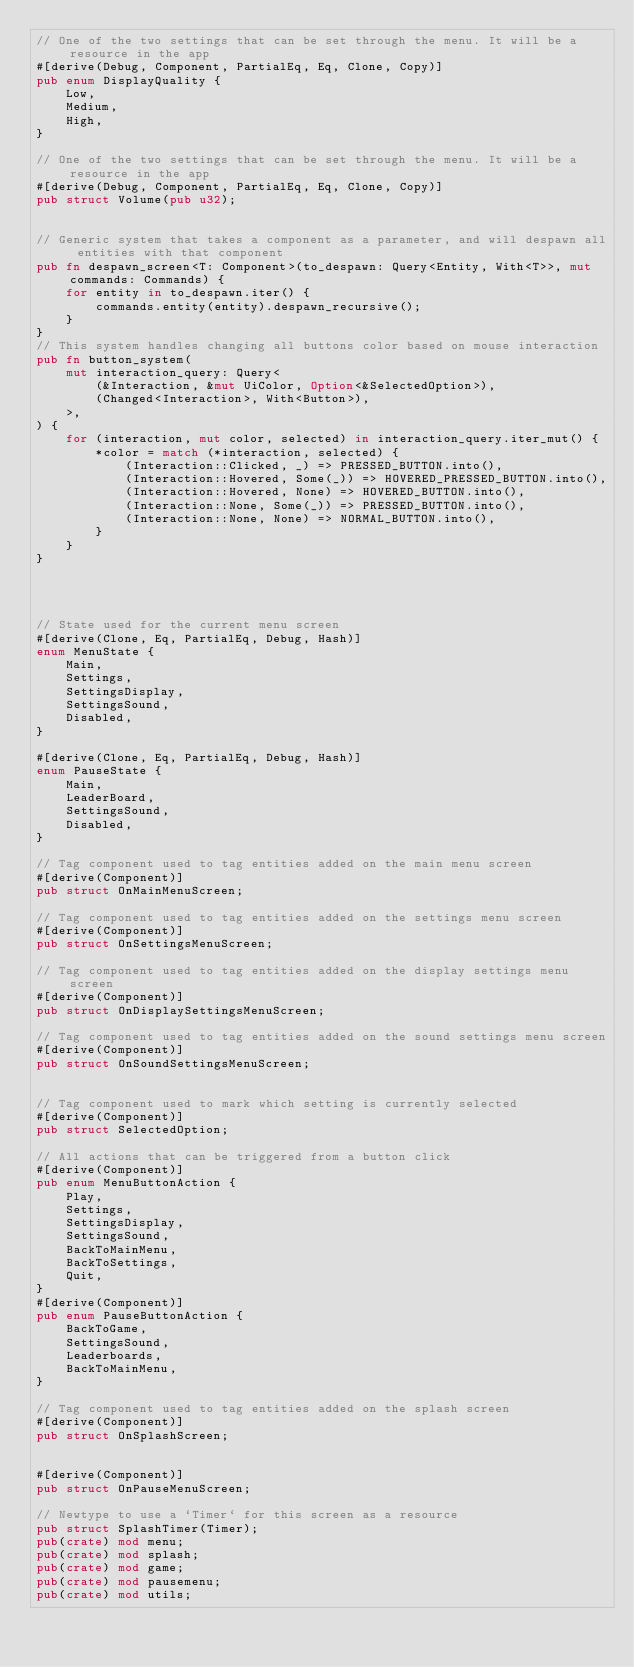Convert code to text. <code><loc_0><loc_0><loc_500><loc_500><_Rust_>// One of the two settings that can be set through the menu. It will be a resource in the app
#[derive(Debug, Component, PartialEq, Eq, Clone, Copy)]
pub enum DisplayQuality {
    Low,
    Medium,
    High,
}

// One of the two settings that can be set through the menu. It will be a resource in the app
#[derive(Debug, Component, PartialEq, Eq, Clone, Copy)]
pub struct Volume(pub u32);


// Generic system that takes a component as a parameter, and will despawn all entities with that component
pub fn despawn_screen<T: Component>(to_despawn: Query<Entity, With<T>>, mut commands: Commands) {
    for entity in to_despawn.iter() {
        commands.entity(entity).despawn_recursive();
    }
}
// This system handles changing all buttons color based on mouse interaction
pub fn button_system(
    mut interaction_query: Query<
        (&Interaction, &mut UiColor, Option<&SelectedOption>),
        (Changed<Interaction>, With<Button>),
    >,
) {
    for (interaction, mut color, selected) in interaction_query.iter_mut() {
        *color = match (*interaction, selected) {
            (Interaction::Clicked, _) => PRESSED_BUTTON.into(),
            (Interaction::Hovered, Some(_)) => HOVERED_PRESSED_BUTTON.into(),
            (Interaction::Hovered, None) => HOVERED_BUTTON.into(),
            (Interaction::None, Some(_)) => PRESSED_BUTTON.into(),
            (Interaction::None, None) => NORMAL_BUTTON.into(),
        }
    }
}




// State used for the current menu screen
#[derive(Clone, Eq, PartialEq, Debug, Hash)]
enum MenuState {
    Main,
    Settings,
    SettingsDisplay,
    SettingsSound,
    Disabled,
}

#[derive(Clone, Eq, PartialEq, Debug, Hash)]
enum PauseState {
    Main,
    LeaderBoard,
    SettingsSound,
    Disabled,
}

// Tag component used to tag entities added on the main menu screen
#[derive(Component)]
pub struct OnMainMenuScreen;

// Tag component used to tag entities added on the settings menu screen
#[derive(Component)]
pub struct OnSettingsMenuScreen;

// Tag component used to tag entities added on the display settings menu screen
#[derive(Component)]
pub struct OnDisplaySettingsMenuScreen;

// Tag component used to tag entities added on the sound settings menu screen
#[derive(Component)]
pub struct OnSoundSettingsMenuScreen;


// Tag component used to mark which setting is currently selected
#[derive(Component)]
pub struct SelectedOption;

// All actions that can be triggered from a button click
#[derive(Component)]
pub enum MenuButtonAction {
    Play,
    Settings,
    SettingsDisplay,
    SettingsSound,
    BackToMainMenu,
    BackToSettings,
    Quit,
}
#[derive(Component)]
pub enum PauseButtonAction {
    BackToGame,
    SettingsSound,
    Leaderboards,
    BackToMainMenu,
}

// Tag component used to tag entities added on the splash screen
#[derive(Component)]
pub struct OnSplashScreen;


#[derive(Component)]
pub struct OnPauseMenuScreen;

// Newtype to use a `Timer` for this screen as a resource
pub struct SplashTimer(Timer);
pub(crate) mod menu;
pub(crate) mod splash;
pub(crate) mod game;
pub(crate) mod pausemenu;
pub(crate) mod utils;</code> 